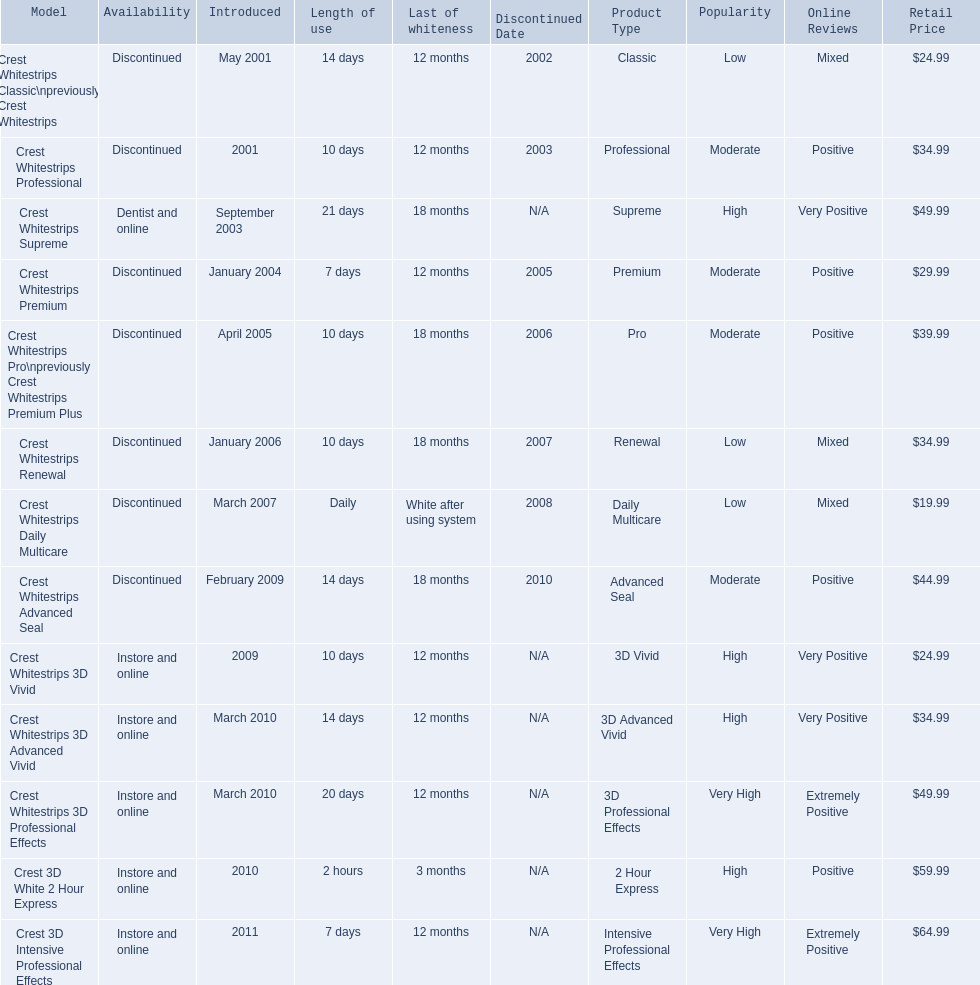When was crest whitestrips 3d advanced vivid introduced? March 2010. What other product was introduced in march 2010? Crest Whitestrips 3D Professional Effects. 